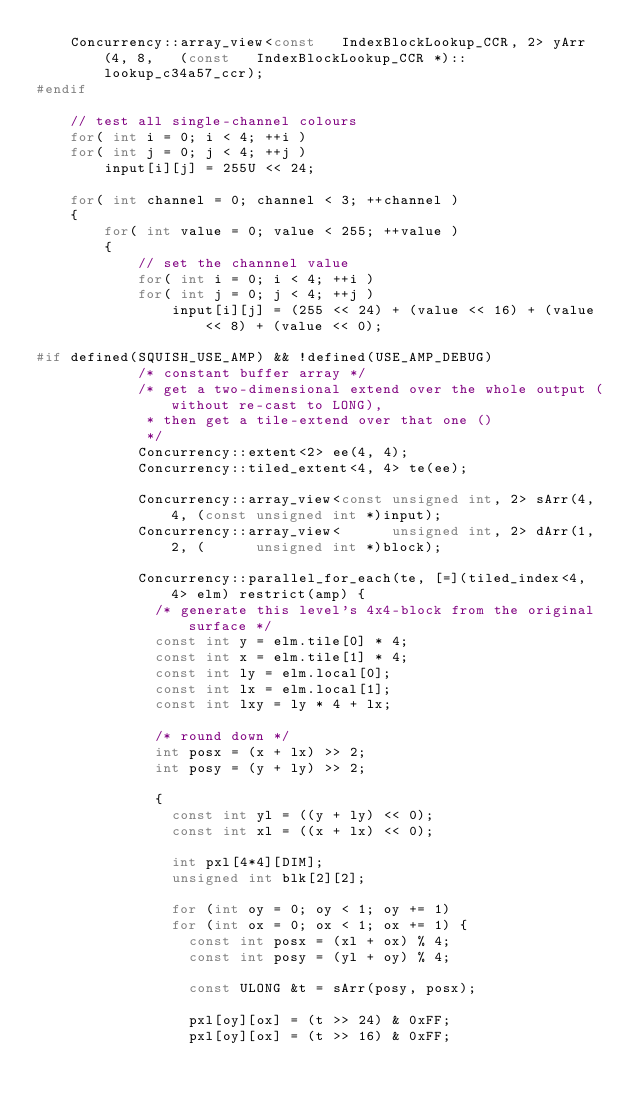Convert code to text. <code><loc_0><loc_0><loc_500><loc_500><_C++_>	Concurrency::array_view<const   IndexBlockLookup_CCR, 2> yArr(4, 8,   (const   IndexBlockLookup_CCR *)::lookup_c34a57_ccr);
#endif

	// test all single-channel colours
	for( int i = 0; i < 4; ++i )
	for( int j = 0; j < 4; ++j )
		input[i][j] = 255U << 24;

	for( int channel = 0; channel < 3; ++channel )
	{
		for( int value = 0; value < 255; ++value )
		{
			// set the channnel value
			for( int i = 0; i < 4; ++i )
			for( int j = 0; j < 4; ++j )
				input[i][j] = (255 << 24) + (value << 16) + (value << 8) + (value << 0);

#if	defined(SQUISH_USE_AMP) && !defined(USE_AMP_DEBUG)
			/* constant buffer array */
			/* get a two-dimensional extend over the whole output (without re-cast to LONG),
			 * then get a tile-extend over that one ()
			 */
			Concurrency::extent<2> ee(4, 4);
			Concurrency::tiled_extent<4, 4> te(ee);

			Concurrency::array_view<const unsigned int, 2> sArr(4, 4, (const unsigned int *)input);
			Concurrency::array_view<      unsigned int, 2> dArr(1, 2, (      unsigned int *)block);

			Concurrency::parallel_for_each(te, [=](tiled_index<4, 4> elm) restrict(amp) {
			  /* generate this level's 4x4-block from the original surface */
			  const int y = elm.tile[0] * 4;
			  const int x = elm.tile[1] * 4;
			  const int ly = elm.local[0];
			  const int lx = elm.local[1];
			  const int lxy = ly * 4 + lx;

			  /* round down */
			  int posx = (x + lx) >> 2;
			  int posy = (y + ly) >> 2;

			  {
			    const int yl = ((y + ly) << 0);
			    const int xl = ((x + lx) << 0);

			    int pxl[4*4][DIM];
			    unsigned int blk[2][2];

			    for (int oy = 0; oy < 1; oy += 1)
			    for (int ox = 0; ox < 1; ox += 1) {
			      const int posx = (xl + ox) % 4;
			      const int posy = (yl + oy) % 4;

			      const ULONG &t = sArr(posy, posx);

			      pxl[oy][ox] = (t >> 24) & 0xFF;
			      pxl[oy][ox] = (t >> 16) & 0xFF;</code> 